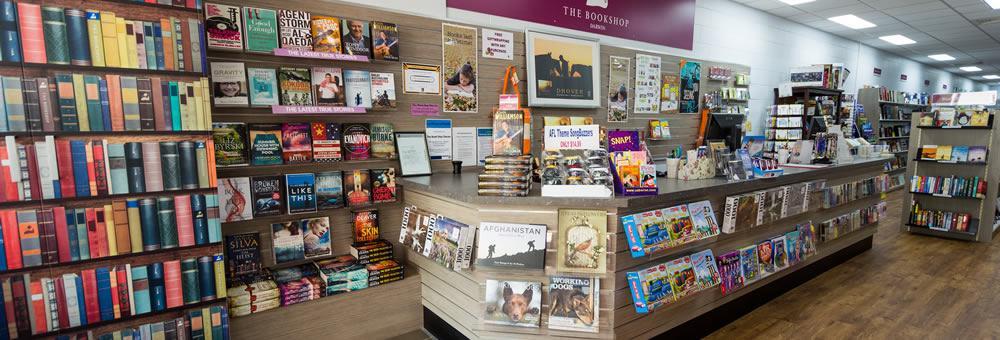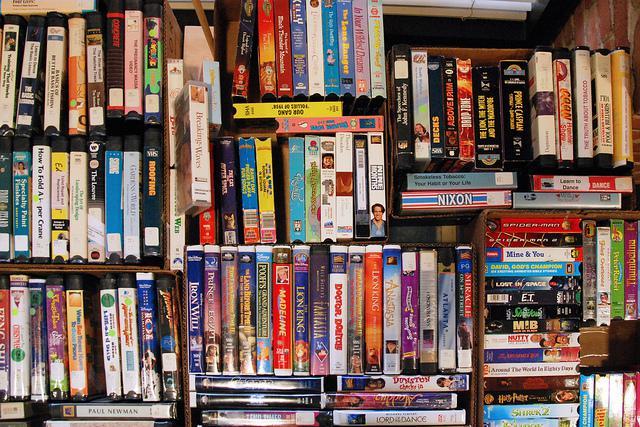The first image is the image on the left, the second image is the image on the right. For the images displayed, is the sentence "There is at least one person in the image on the left." factually correct? Answer yes or no. No. 